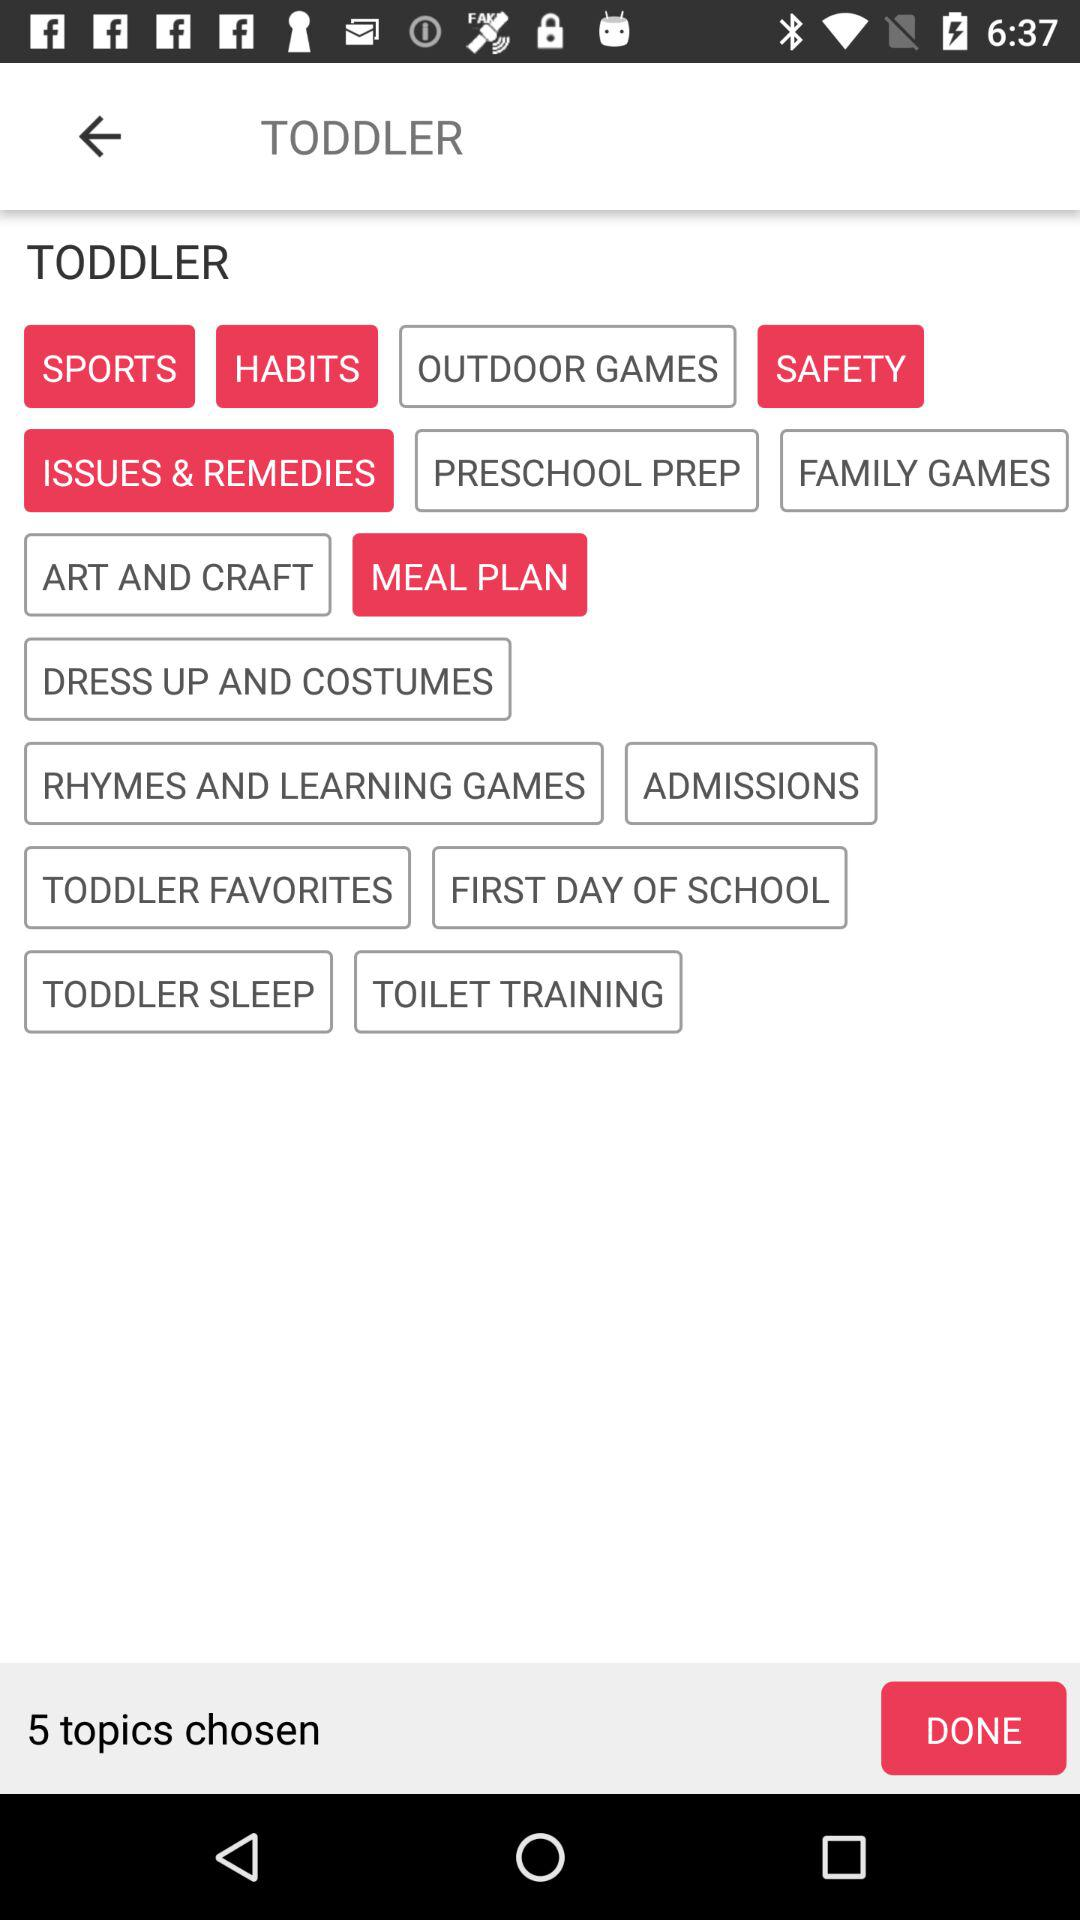How many topics does the toddler have?
Answer the question using a single word or phrase. 5 